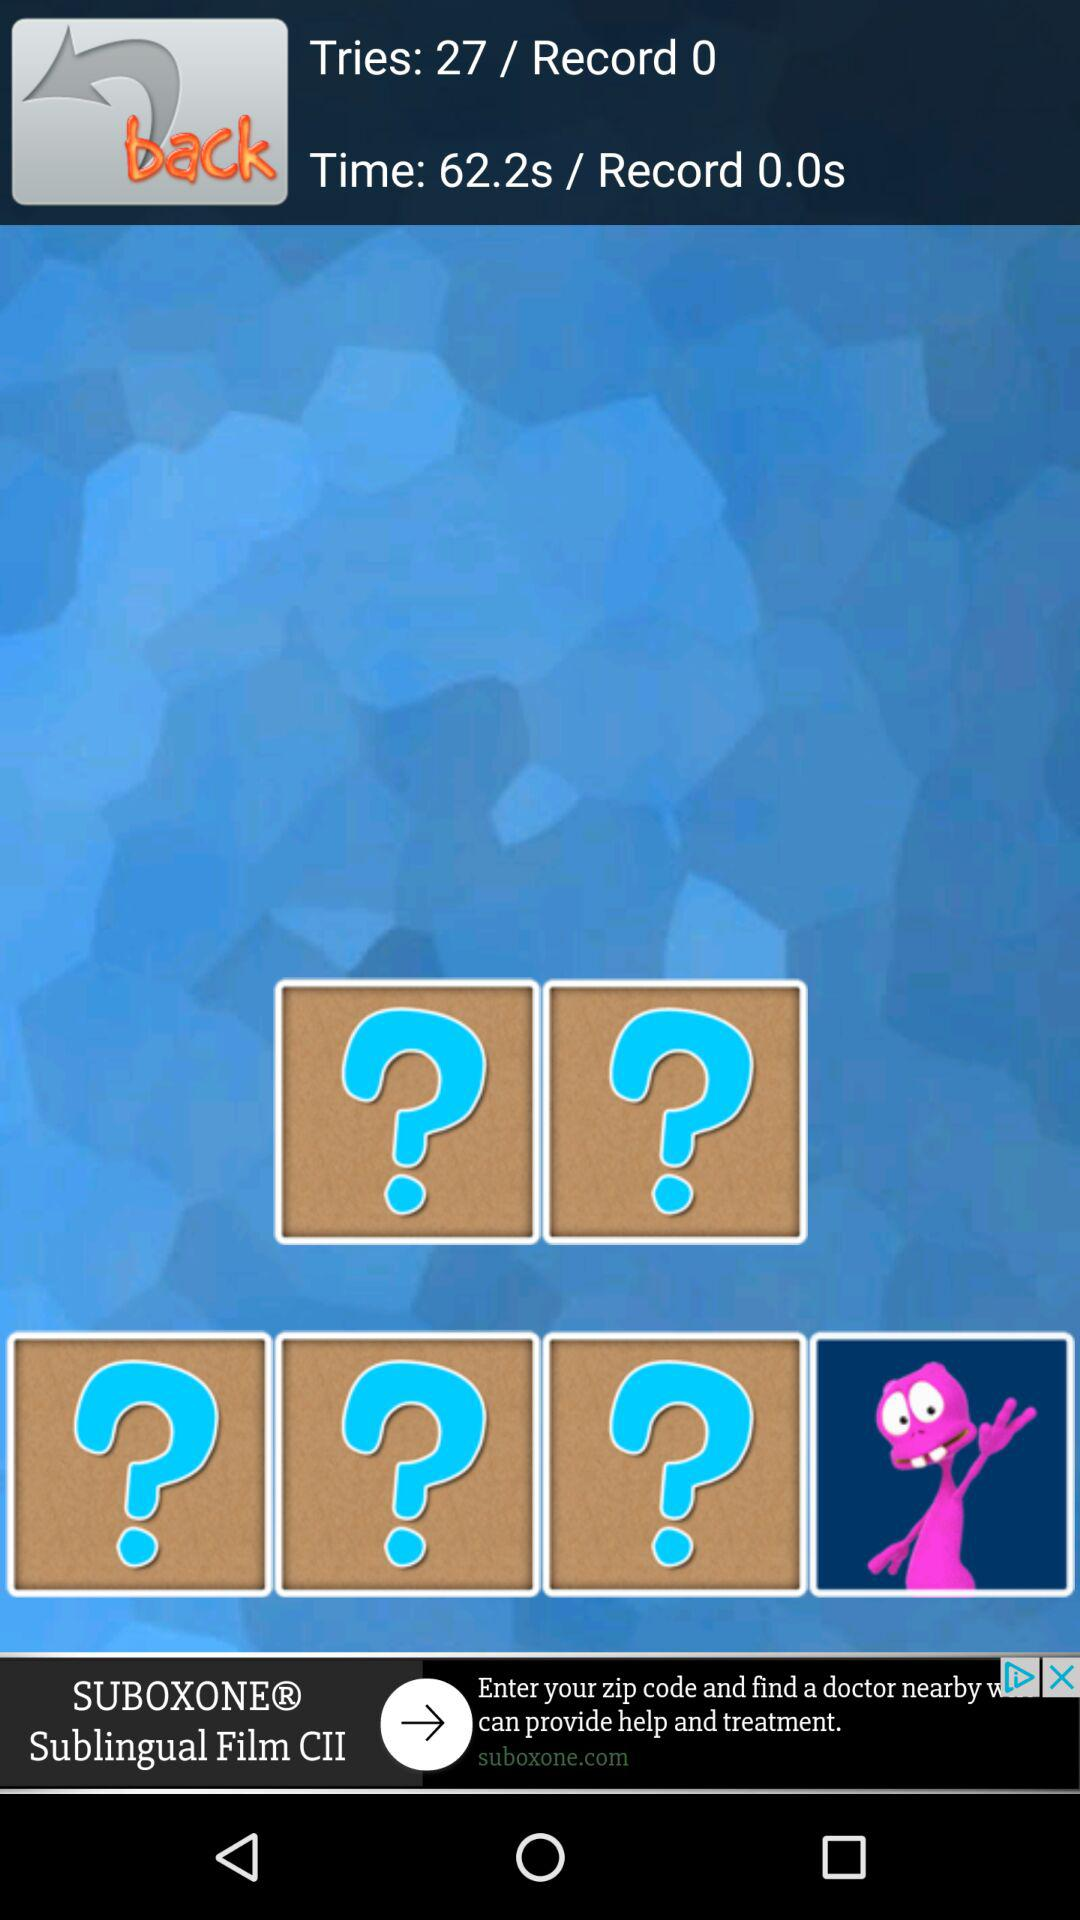What is the count in tries? The count in tries is 27. 